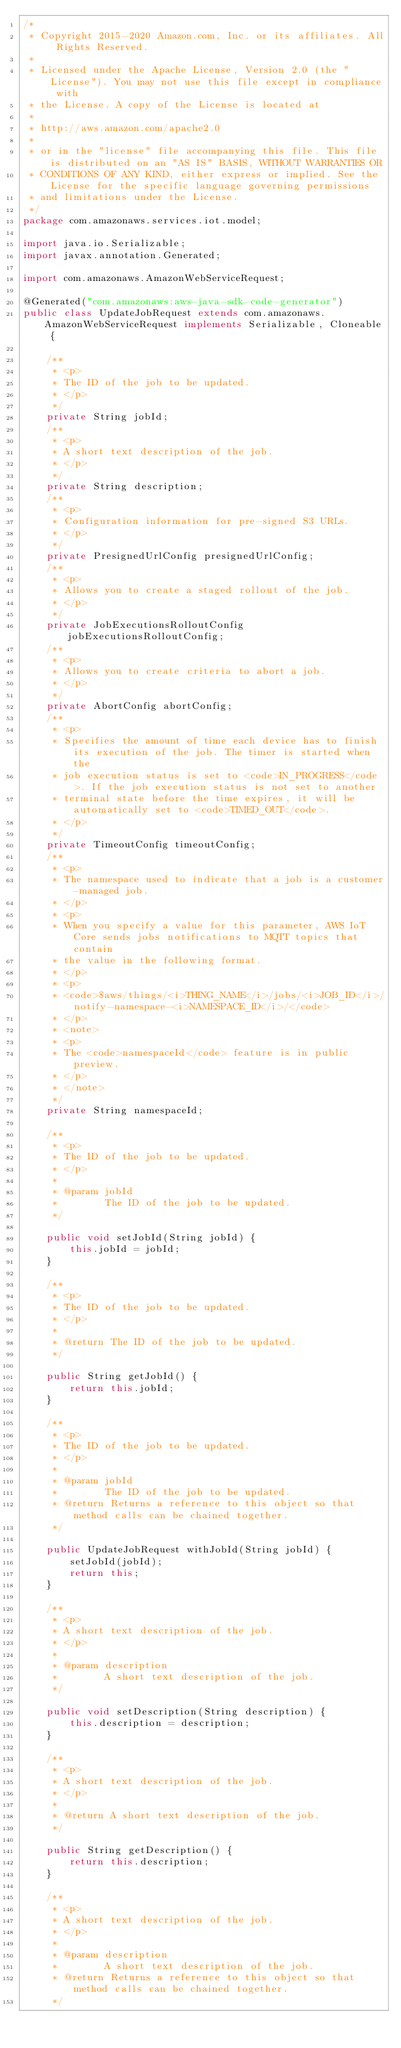Convert code to text. <code><loc_0><loc_0><loc_500><loc_500><_Java_>/*
 * Copyright 2015-2020 Amazon.com, Inc. or its affiliates. All Rights Reserved.
 * 
 * Licensed under the Apache License, Version 2.0 (the "License"). You may not use this file except in compliance with
 * the License. A copy of the License is located at
 * 
 * http://aws.amazon.com/apache2.0
 * 
 * or in the "license" file accompanying this file. This file is distributed on an "AS IS" BASIS, WITHOUT WARRANTIES OR
 * CONDITIONS OF ANY KIND, either express or implied. See the License for the specific language governing permissions
 * and limitations under the License.
 */
package com.amazonaws.services.iot.model;

import java.io.Serializable;
import javax.annotation.Generated;

import com.amazonaws.AmazonWebServiceRequest;

@Generated("com.amazonaws:aws-java-sdk-code-generator")
public class UpdateJobRequest extends com.amazonaws.AmazonWebServiceRequest implements Serializable, Cloneable {

    /**
     * <p>
     * The ID of the job to be updated.
     * </p>
     */
    private String jobId;
    /**
     * <p>
     * A short text description of the job.
     * </p>
     */
    private String description;
    /**
     * <p>
     * Configuration information for pre-signed S3 URLs.
     * </p>
     */
    private PresignedUrlConfig presignedUrlConfig;
    /**
     * <p>
     * Allows you to create a staged rollout of the job.
     * </p>
     */
    private JobExecutionsRolloutConfig jobExecutionsRolloutConfig;
    /**
     * <p>
     * Allows you to create criteria to abort a job.
     * </p>
     */
    private AbortConfig abortConfig;
    /**
     * <p>
     * Specifies the amount of time each device has to finish its execution of the job. The timer is started when the
     * job execution status is set to <code>IN_PROGRESS</code>. If the job execution status is not set to another
     * terminal state before the time expires, it will be automatically set to <code>TIMED_OUT</code>.
     * </p>
     */
    private TimeoutConfig timeoutConfig;
    /**
     * <p>
     * The namespace used to indicate that a job is a customer-managed job.
     * </p>
     * <p>
     * When you specify a value for this parameter, AWS IoT Core sends jobs notifications to MQTT topics that contain
     * the value in the following format.
     * </p>
     * <p>
     * <code>$aws/things/<i>THING_NAME</i>/jobs/<i>JOB_ID</i>/notify-namespace-<i>NAMESPACE_ID</i>/</code>
     * </p>
     * <note>
     * <p>
     * The <code>namespaceId</code> feature is in public preview.
     * </p>
     * </note>
     */
    private String namespaceId;

    /**
     * <p>
     * The ID of the job to be updated.
     * </p>
     * 
     * @param jobId
     *        The ID of the job to be updated.
     */

    public void setJobId(String jobId) {
        this.jobId = jobId;
    }

    /**
     * <p>
     * The ID of the job to be updated.
     * </p>
     * 
     * @return The ID of the job to be updated.
     */

    public String getJobId() {
        return this.jobId;
    }

    /**
     * <p>
     * The ID of the job to be updated.
     * </p>
     * 
     * @param jobId
     *        The ID of the job to be updated.
     * @return Returns a reference to this object so that method calls can be chained together.
     */

    public UpdateJobRequest withJobId(String jobId) {
        setJobId(jobId);
        return this;
    }

    /**
     * <p>
     * A short text description of the job.
     * </p>
     * 
     * @param description
     *        A short text description of the job.
     */

    public void setDescription(String description) {
        this.description = description;
    }

    /**
     * <p>
     * A short text description of the job.
     * </p>
     * 
     * @return A short text description of the job.
     */

    public String getDescription() {
        return this.description;
    }

    /**
     * <p>
     * A short text description of the job.
     * </p>
     * 
     * @param description
     *        A short text description of the job.
     * @return Returns a reference to this object so that method calls can be chained together.
     */
</code> 